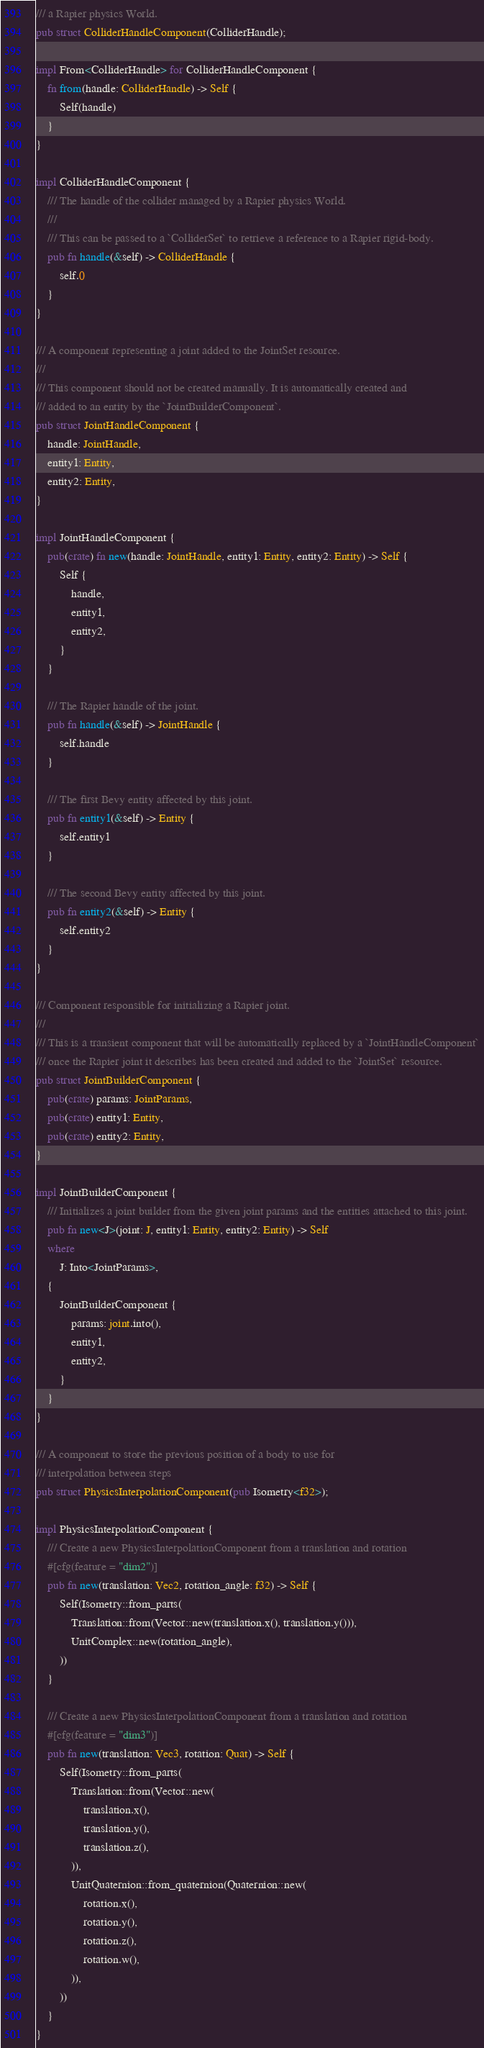<code> <loc_0><loc_0><loc_500><loc_500><_Rust_>/// a Rapier physics World.
pub struct ColliderHandleComponent(ColliderHandle);

impl From<ColliderHandle> for ColliderHandleComponent {
    fn from(handle: ColliderHandle) -> Self {
        Self(handle)
    }
}

impl ColliderHandleComponent {
    /// The handle of the collider managed by a Rapier physics World.
    ///
    /// This can be passed to a `ColliderSet` to retrieve a reference to a Rapier rigid-body.
    pub fn handle(&self) -> ColliderHandle {
        self.0
    }
}

/// A component representing a joint added to the JointSet resource.
///
/// This component should not be created manually. It is automatically created and
/// added to an entity by the `JointBuilderComponent`.
pub struct JointHandleComponent {
    handle: JointHandle,
    entity1: Entity,
    entity2: Entity,
}

impl JointHandleComponent {
    pub(crate) fn new(handle: JointHandle, entity1: Entity, entity2: Entity) -> Self {
        Self {
            handle,
            entity1,
            entity2,
        }
    }

    /// The Rapier handle of the joint.
    pub fn handle(&self) -> JointHandle {
        self.handle
    }

    /// The first Bevy entity affected by this joint.
    pub fn entity1(&self) -> Entity {
        self.entity1
    }

    /// The second Bevy entity affected by this joint.
    pub fn entity2(&self) -> Entity {
        self.entity2
    }
}

/// Component responsible for initializing a Rapier joint.
///
/// This is a transient component that will be automatically replaced by a `JointHandleComponent`
/// once the Rapier joint it describes has been created and added to the `JointSet` resource.
pub struct JointBuilderComponent {
    pub(crate) params: JointParams,
    pub(crate) entity1: Entity,
    pub(crate) entity2: Entity,
}

impl JointBuilderComponent {
    /// Initializes a joint builder from the given joint params and the entities attached to this joint.
    pub fn new<J>(joint: J, entity1: Entity, entity2: Entity) -> Self
    where
        J: Into<JointParams>,
    {
        JointBuilderComponent {
            params: joint.into(),
            entity1,
            entity2,
        }
    }
}

/// A component to store the previous position of a body to use for
/// interpolation between steps
pub struct PhysicsInterpolationComponent(pub Isometry<f32>);

impl PhysicsInterpolationComponent {
    /// Create a new PhysicsInterpolationComponent from a translation and rotation
    #[cfg(feature = "dim2")]
    pub fn new(translation: Vec2, rotation_angle: f32) -> Self {
        Self(Isometry::from_parts(
            Translation::from(Vector::new(translation.x(), translation.y())),
            UnitComplex::new(rotation_angle),
        ))
    }

    /// Create a new PhysicsInterpolationComponent from a translation and rotation
    #[cfg(feature = "dim3")]
    pub fn new(translation: Vec3, rotation: Quat) -> Self {
        Self(Isometry::from_parts(
            Translation::from(Vector::new(
                translation.x(),
                translation.y(),
                translation.z(),
            )),
            UnitQuaternion::from_quaternion(Quaternion::new(
                rotation.x(),
                rotation.y(),
                rotation.z(),
                rotation.w(),
            )),
        ))
    }
}
</code> 